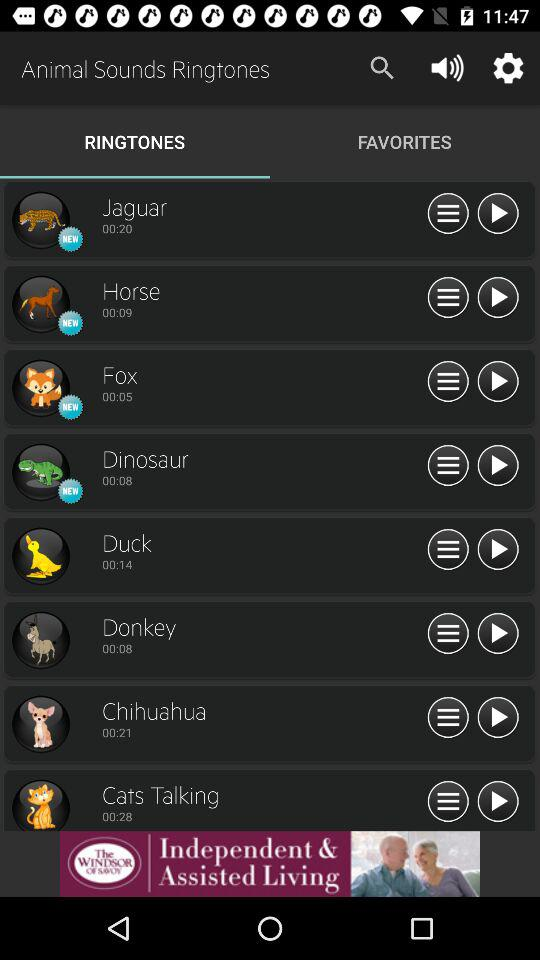How long is the "Horse" ringtone? The "Horse" ringtone is 9 seconds long. 